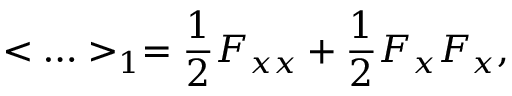<formula> <loc_0><loc_0><loc_500><loc_500>< \dots > _ { 1 } = { \frac { 1 } { 2 } } F _ { x x } + { \frac { 1 } { 2 } } F _ { x } F _ { x } ,</formula> 